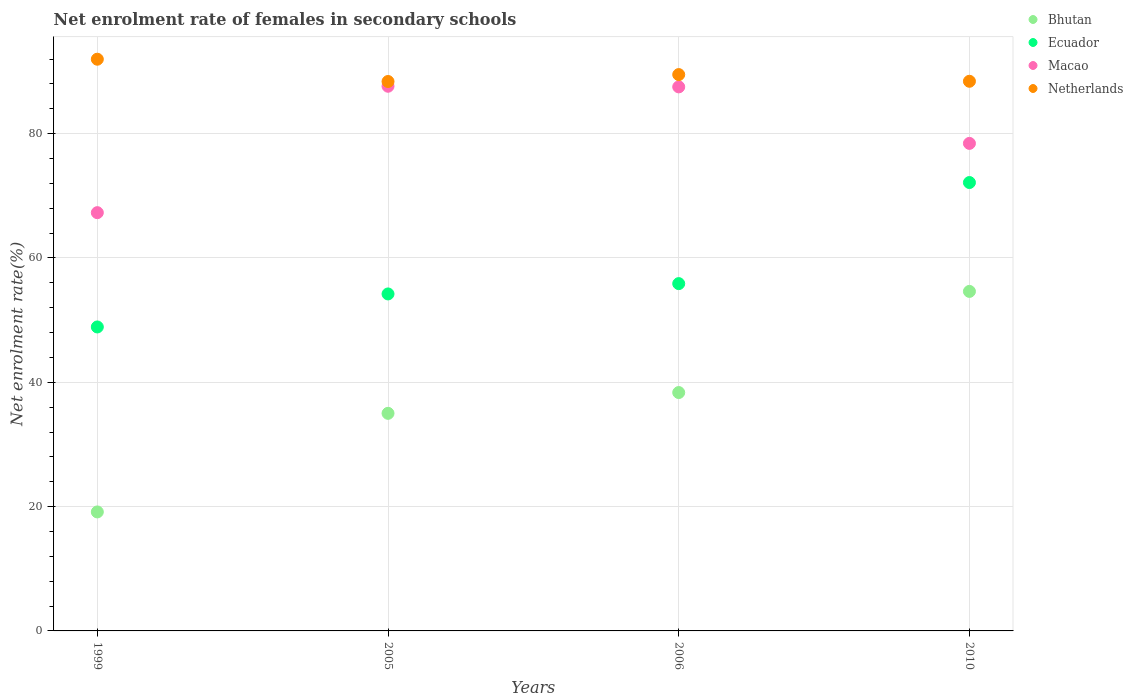How many different coloured dotlines are there?
Provide a succinct answer. 4. What is the net enrolment rate of females in secondary schools in Netherlands in 2010?
Make the answer very short. 88.43. Across all years, what is the maximum net enrolment rate of females in secondary schools in Netherlands?
Your answer should be very brief. 91.98. Across all years, what is the minimum net enrolment rate of females in secondary schools in Ecuador?
Your answer should be compact. 48.9. In which year was the net enrolment rate of females in secondary schools in Netherlands minimum?
Provide a short and direct response. 2005. What is the total net enrolment rate of females in secondary schools in Netherlands in the graph?
Offer a terse response. 358.3. What is the difference between the net enrolment rate of females in secondary schools in Ecuador in 2005 and that in 2006?
Your answer should be very brief. -1.66. What is the difference between the net enrolment rate of females in secondary schools in Netherlands in 2006 and the net enrolment rate of females in secondary schools in Ecuador in 2010?
Your answer should be compact. 17.37. What is the average net enrolment rate of females in secondary schools in Macao per year?
Offer a very short reply. 80.22. In the year 1999, what is the difference between the net enrolment rate of females in secondary schools in Ecuador and net enrolment rate of females in secondary schools in Netherlands?
Your response must be concise. -43.08. What is the ratio of the net enrolment rate of females in secondary schools in Ecuador in 2005 to that in 2010?
Provide a short and direct response. 0.75. What is the difference between the highest and the second highest net enrolment rate of females in secondary schools in Macao?
Provide a short and direct response. 0.1. What is the difference between the highest and the lowest net enrolment rate of females in secondary schools in Macao?
Your answer should be compact. 20.34. Is the sum of the net enrolment rate of females in secondary schools in Netherlands in 2005 and 2006 greater than the maximum net enrolment rate of females in secondary schools in Macao across all years?
Your response must be concise. Yes. Is it the case that in every year, the sum of the net enrolment rate of females in secondary schools in Bhutan and net enrolment rate of females in secondary schools in Ecuador  is greater than the sum of net enrolment rate of females in secondary schools in Netherlands and net enrolment rate of females in secondary schools in Macao?
Your response must be concise. No. Does the net enrolment rate of females in secondary schools in Bhutan monotonically increase over the years?
Provide a short and direct response. Yes. How many dotlines are there?
Your response must be concise. 4. How many years are there in the graph?
Offer a very short reply. 4. Does the graph contain grids?
Provide a short and direct response. Yes. What is the title of the graph?
Your answer should be very brief. Net enrolment rate of females in secondary schools. Does "Georgia" appear as one of the legend labels in the graph?
Keep it short and to the point. No. What is the label or title of the X-axis?
Offer a terse response. Years. What is the label or title of the Y-axis?
Your response must be concise. Net enrolment rate(%). What is the Net enrolment rate(%) in Bhutan in 1999?
Your answer should be compact. 19.14. What is the Net enrolment rate(%) in Ecuador in 1999?
Provide a succinct answer. 48.9. What is the Net enrolment rate(%) of Macao in 1999?
Your answer should be very brief. 67.29. What is the Net enrolment rate(%) in Netherlands in 1999?
Offer a very short reply. 91.98. What is the Net enrolment rate(%) of Bhutan in 2005?
Your response must be concise. 35.01. What is the Net enrolment rate(%) of Ecuador in 2005?
Keep it short and to the point. 54.21. What is the Net enrolment rate(%) in Macao in 2005?
Make the answer very short. 87.63. What is the Net enrolment rate(%) of Netherlands in 2005?
Offer a very short reply. 88.39. What is the Net enrolment rate(%) of Bhutan in 2006?
Ensure brevity in your answer.  38.35. What is the Net enrolment rate(%) in Ecuador in 2006?
Your answer should be very brief. 55.87. What is the Net enrolment rate(%) of Macao in 2006?
Offer a very short reply. 87.53. What is the Net enrolment rate(%) in Netherlands in 2006?
Provide a succinct answer. 89.5. What is the Net enrolment rate(%) in Bhutan in 2010?
Your answer should be very brief. 54.62. What is the Net enrolment rate(%) of Ecuador in 2010?
Give a very brief answer. 72.14. What is the Net enrolment rate(%) of Macao in 2010?
Your answer should be very brief. 78.43. What is the Net enrolment rate(%) in Netherlands in 2010?
Provide a succinct answer. 88.43. Across all years, what is the maximum Net enrolment rate(%) of Bhutan?
Offer a very short reply. 54.62. Across all years, what is the maximum Net enrolment rate(%) in Ecuador?
Provide a short and direct response. 72.14. Across all years, what is the maximum Net enrolment rate(%) of Macao?
Your response must be concise. 87.63. Across all years, what is the maximum Net enrolment rate(%) of Netherlands?
Your answer should be very brief. 91.98. Across all years, what is the minimum Net enrolment rate(%) of Bhutan?
Your answer should be very brief. 19.14. Across all years, what is the minimum Net enrolment rate(%) in Ecuador?
Provide a short and direct response. 48.9. Across all years, what is the minimum Net enrolment rate(%) of Macao?
Your answer should be very brief. 67.29. Across all years, what is the minimum Net enrolment rate(%) of Netherlands?
Offer a terse response. 88.39. What is the total Net enrolment rate(%) in Bhutan in the graph?
Give a very brief answer. 147.12. What is the total Net enrolment rate(%) in Ecuador in the graph?
Offer a terse response. 231.13. What is the total Net enrolment rate(%) of Macao in the graph?
Your response must be concise. 320.88. What is the total Net enrolment rate(%) of Netherlands in the graph?
Ensure brevity in your answer.  358.3. What is the difference between the Net enrolment rate(%) of Bhutan in 1999 and that in 2005?
Offer a very short reply. -15.86. What is the difference between the Net enrolment rate(%) in Ecuador in 1999 and that in 2005?
Provide a succinct answer. -5.31. What is the difference between the Net enrolment rate(%) of Macao in 1999 and that in 2005?
Your answer should be compact. -20.34. What is the difference between the Net enrolment rate(%) in Netherlands in 1999 and that in 2005?
Keep it short and to the point. 3.58. What is the difference between the Net enrolment rate(%) of Bhutan in 1999 and that in 2006?
Provide a succinct answer. -19.21. What is the difference between the Net enrolment rate(%) in Ecuador in 1999 and that in 2006?
Offer a terse response. -6.97. What is the difference between the Net enrolment rate(%) of Macao in 1999 and that in 2006?
Offer a very short reply. -20.24. What is the difference between the Net enrolment rate(%) of Netherlands in 1999 and that in 2006?
Offer a terse response. 2.47. What is the difference between the Net enrolment rate(%) in Bhutan in 1999 and that in 2010?
Offer a terse response. -35.48. What is the difference between the Net enrolment rate(%) of Ecuador in 1999 and that in 2010?
Offer a very short reply. -23.23. What is the difference between the Net enrolment rate(%) of Macao in 1999 and that in 2010?
Provide a succinct answer. -11.14. What is the difference between the Net enrolment rate(%) in Netherlands in 1999 and that in 2010?
Your answer should be compact. 3.55. What is the difference between the Net enrolment rate(%) in Bhutan in 2005 and that in 2006?
Your response must be concise. -3.34. What is the difference between the Net enrolment rate(%) in Ecuador in 2005 and that in 2006?
Offer a very short reply. -1.66. What is the difference between the Net enrolment rate(%) of Macao in 2005 and that in 2006?
Offer a terse response. 0.1. What is the difference between the Net enrolment rate(%) in Netherlands in 2005 and that in 2006?
Ensure brevity in your answer.  -1.11. What is the difference between the Net enrolment rate(%) in Bhutan in 2005 and that in 2010?
Keep it short and to the point. -19.62. What is the difference between the Net enrolment rate(%) in Ecuador in 2005 and that in 2010?
Give a very brief answer. -17.92. What is the difference between the Net enrolment rate(%) in Macao in 2005 and that in 2010?
Ensure brevity in your answer.  9.19. What is the difference between the Net enrolment rate(%) in Netherlands in 2005 and that in 2010?
Keep it short and to the point. -0.04. What is the difference between the Net enrolment rate(%) in Bhutan in 2006 and that in 2010?
Your answer should be very brief. -16.27. What is the difference between the Net enrolment rate(%) of Ecuador in 2006 and that in 2010?
Offer a very short reply. -16.26. What is the difference between the Net enrolment rate(%) of Macao in 2006 and that in 2010?
Offer a very short reply. 9.09. What is the difference between the Net enrolment rate(%) of Netherlands in 2006 and that in 2010?
Keep it short and to the point. 1.08. What is the difference between the Net enrolment rate(%) in Bhutan in 1999 and the Net enrolment rate(%) in Ecuador in 2005?
Give a very brief answer. -35.07. What is the difference between the Net enrolment rate(%) in Bhutan in 1999 and the Net enrolment rate(%) in Macao in 2005?
Make the answer very short. -68.49. What is the difference between the Net enrolment rate(%) in Bhutan in 1999 and the Net enrolment rate(%) in Netherlands in 2005?
Your response must be concise. -69.25. What is the difference between the Net enrolment rate(%) of Ecuador in 1999 and the Net enrolment rate(%) of Macao in 2005?
Your answer should be compact. -38.73. What is the difference between the Net enrolment rate(%) of Ecuador in 1999 and the Net enrolment rate(%) of Netherlands in 2005?
Offer a very short reply. -39.49. What is the difference between the Net enrolment rate(%) of Macao in 1999 and the Net enrolment rate(%) of Netherlands in 2005?
Your response must be concise. -21.1. What is the difference between the Net enrolment rate(%) of Bhutan in 1999 and the Net enrolment rate(%) of Ecuador in 2006?
Your answer should be very brief. -36.73. What is the difference between the Net enrolment rate(%) in Bhutan in 1999 and the Net enrolment rate(%) in Macao in 2006?
Your answer should be very brief. -68.38. What is the difference between the Net enrolment rate(%) in Bhutan in 1999 and the Net enrolment rate(%) in Netherlands in 2006?
Ensure brevity in your answer.  -70.36. What is the difference between the Net enrolment rate(%) of Ecuador in 1999 and the Net enrolment rate(%) of Macao in 2006?
Your answer should be compact. -38.62. What is the difference between the Net enrolment rate(%) of Ecuador in 1999 and the Net enrolment rate(%) of Netherlands in 2006?
Your answer should be compact. -40.6. What is the difference between the Net enrolment rate(%) in Macao in 1999 and the Net enrolment rate(%) in Netherlands in 2006?
Provide a succinct answer. -22.21. What is the difference between the Net enrolment rate(%) of Bhutan in 1999 and the Net enrolment rate(%) of Ecuador in 2010?
Make the answer very short. -52.99. What is the difference between the Net enrolment rate(%) in Bhutan in 1999 and the Net enrolment rate(%) in Macao in 2010?
Offer a very short reply. -59.29. What is the difference between the Net enrolment rate(%) in Bhutan in 1999 and the Net enrolment rate(%) in Netherlands in 2010?
Your answer should be compact. -69.28. What is the difference between the Net enrolment rate(%) in Ecuador in 1999 and the Net enrolment rate(%) in Macao in 2010?
Make the answer very short. -29.53. What is the difference between the Net enrolment rate(%) of Ecuador in 1999 and the Net enrolment rate(%) of Netherlands in 2010?
Keep it short and to the point. -39.53. What is the difference between the Net enrolment rate(%) of Macao in 1999 and the Net enrolment rate(%) of Netherlands in 2010?
Make the answer very short. -21.14. What is the difference between the Net enrolment rate(%) in Bhutan in 2005 and the Net enrolment rate(%) in Ecuador in 2006?
Make the answer very short. -20.87. What is the difference between the Net enrolment rate(%) in Bhutan in 2005 and the Net enrolment rate(%) in Macao in 2006?
Ensure brevity in your answer.  -52.52. What is the difference between the Net enrolment rate(%) of Bhutan in 2005 and the Net enrolment rate(%) of Netherlands in 2006?
Provide a succinct answer. -54.5. What is the difference between the Net enrolment rate(%) in Ecuador in 2005 and the Net enrolment rate(%) in Macao in 2006?
Make the answer very short. -33.31. What is the difference between the Net enrolment rate(%) in Ecuador in 2005 and the Net enrolment rate(%) in Netherlands in 2006?
Your answer should be compact. -35.29. What is the difference between the Net enrolment rate(%) in Macao in 2005 and the Net enrolment rate(%) in Netherlands in 2006?
Your answer should be very brief. -1.88. What is the difference between the Net enrolment rate(%) in Bhutan in 2005 and the Net enrolment rate(%) in Ecuador in 2010?
Your answer should be compact. -37.13. What is the difference between the Net enrolment rate(%) in Bhutan in 2005 and the Net enrolment rate(%) in Macao in 2010?
Keep it short and to the point. -43.43. What is the difference between the Net enrolment rate(%) in Bhutan in 2005 and the Net enrolment rate(%) in Netherlands in 2010?
Make the answer very short. -53.42. What is the difference between the Net enrolment rate(%) in Ecuador in 2005 and the Net enrolment rate(%) in Macao in 2010?
Your response must be concise. -24.22. What is the difference between the Net enrolment rate(%) in Ecuador in 2005 and the Net enrolment rate(%) in Netherlands in 2010?
Your response must be concise. -34.21. What is the difference between the Net enrolment rate(%) in Macao in 2005 and the Net enrolment rate(%) in Netherlands in 2010?
Make the answer very short. -0.8. What is the difference between the Net enrolment rate(%) in Bhutan in 2006 and the Net enrolment rate(%) in Ecuador in 2010?
Offer a very short reply. -33.79. What is the difference between the Net enrolment rate(%) in Bhutan in 2006 and the Net enrolment rate(%) in Macao in 2010?
Your response must be concise. -40.08. What is the difference between the Net enrolment rate(%) in Bhutan in 2006 and the Net enrolment rate(%) in Netherlands in 2010?
Make the answer very short. -50.08. What is the difference between the Net enrolment rate(%) of Ecuador in 2006 and the Net enrolment rate(%) of Macao in 2010?
Provide a short and direct response. -22.56. What is the difference between the Net enrolment rate(%) in Ecuador in 2006 and the Net enrolment rate(%) in Netherlands in 2010?
Your answer should be compact. -32.55. What is the difference between the Net enrolment rate(%) of Macao in 2006 and the Net enrolment rate(%) of Netherlands in 2010?
Make the answer very short. -0.9. What is the average Net enrolment rate(%) of Bhutan per year?
Make the answer very short. 36.78. What is the average Net enrolment rate(%) in Ecuador per year?
Your answer should be very brief. 57.78. What is the average Net enrolment rate(%) of Macao per year?
Provide a short and direct response. 80.22. What is the average Net enrolment rate(%) of Netherlands per year?
Offer a very short reply. 89.58. In the year 1999, what is the difference between the Net enrolment rate(%) in Bhutan and Net enrolment rate(%) in Ecuador?
Provide a succinct answer. -29.76. In the year 1999, what is the difference between the Net enrolment rate(%) in Bhutan and Net enrolment rate(%) in Macao?
Provide a short and direct response. -48.15. In the year 1999, what is the difference between the Net enrolment rate(%) of Bhutan and Net enrolment rate(%) of Netherlands?
Keep it short and to the point. -72.83. In the year 1999, what is the difference between the Net enrolment rate(%) of Ecuador and Net enrolment rate(%) of Macao?
Give a very brief answer. -18.39. In the year 1999, what is the difference between the Net enrolment rate(%) in Ecuador and Net enrolment rate(%) in Netherlands?
Keep it short and to the point. -43.08. In the year 1999, what is the difference between the Net enrolment rate(%) in Macao and Net enrolment rate(%) in Netherlands?
Offer a terse response. -24.69. In the year 2005, what is the difference between the Net enrolment rate(%) of Bhutan and Net enrolment rate(%) of Ecuador?
Make the answer very short. -19.21. In the year 2005, what is the difference between the Net enrolment rate(%) of Bhutan and Net enrolment rate(%) of Macao?
Offer a very short reply. -52.62. In the year 2005, what is the difference between the Net enrolment rate(%) of Bhutan and Net enrolment rate(%) of Netherlands?
Keep it short and to the point. -53.39. In the year 2005, what is the difference between the Net enrolment rate(%) in Ecuador and Net enrolment rate(%) in Macao?
Your response must be concise. -33.41. In the year 2005, what is the difference between the Net enrolment rate(%) of Ecuador and Net enrolment rate(%) of Netherlands?
Your response must be concise. -34.18. In the year 2005, what is the difference between the Net enrolment rate(%) in Macao and Net enrolment rate(%) in Netherlands?
Offer a terse response. -0.76. In the year 2006, what is the difference between the Net enrolment rate(%) of Bhutan and Net enrolment rate(%) of Ecuador?
Give a very brief answer. -17.52. In the year 2006, what is the difference between the Net enrolment rate(%) of Bhutan and Net enrolment rate(%) of Macao?
Keep it short and to the point. -49.18. In the year 2006, what is the difference between the Net enrolment rate(%) in Bhutan and Net enrolment rate(%) in Netherlands?
Ensure brevity in your answer.  -51.15. In the year 2006, what is the difference between the Net enrolment rate(%) in Ecuador and Net enrolment rate(%) in Macao?
Keep it short and to the point. -31.65. In the year 2006, what is the difference between the Net enrolment rate(%) of Ecuador and Net enrolment rate(%) of Netherlands?
Keep it short and to the point. -33.63. In the year 2006, what is the difference between the Net enrolment rate(%) of Macao and Net enrolment rate(%) of Netherlands?
Offer a very short reply. -1.98. In the year 2010, what is the difference between the Net enrolment rate(%) of Bhutan and Net enrolment rate(%) of Ecuador?
Make the answer very short. -17.51. In the year 2010, what is the difference between the Net enrolment rate(%) of Bhutan and Net enrolment rate(%) of Macao?
Ensure brevity in your answer.  -23.81. In the year 2010, what is the difference between the Net enrolment rate(%) in Bhutan and Net enrolment rate(%) in Netherlands?
Your answer should be very brief. -33.81. In the year 2010, what is the difference between the Net enrolment rate(%) in Ecuador and Net enrolment rate(%) in Macao?
Give a very brief answer. -6.3. In the year 2010, what is the difference between the Net enrolment rate(%) of Ecuador and Net enrolment rate(%) of Netherlands?
Give a very brief answer. -16.29. In the year 2010, what is the difference between the Net enrolment rate(%) in Macao and Net enrolment rate(%) in Netherlands?
Provide a succinct answer. -9.99. What is the ratio of the Net enrolment rate(%) of Bhutan in 1999 to that in 2005?
Keep it short and to the point. 0.55. What is the ratio of the Net enrolment rate(%) in Ecuador in 1999 to that in 2005?
Give a very brief answer. 0.9. What is the ratio of the Net enrolment rate(%) of Macao in 1999 to that in 2005?
Your answer should be very brief. 0.77. What is the ratio of the Net enrolment rate(%) of Netherlands in 1999 to that in 2005?
Ensure brevity in your answer.  1.04. What is the ratio of the Net enrolment rate(%) of Bhutan in 1999 to that in 2006?
Provide a succinct answer. 0.5. What is the ratio of the Net enrolment rate(%) of Ecuador in 1999 to that in 2006?
Keep it short and to the point. 0.88. What is the ratio of the Net enrolment rate(%) in Macao in 1999 to that in 2006?
Keep it short and to the point. 0.77. What is the ratio of the Net enrolment rate(%) in Netherlands in 1999 to that in 2006?
Ensure brevity in your answer.  1.03. What is the ratio of the Net enrolment rate(%) of Bhutan in 1999 to that in 2010?
Your answer should be compact. 0.35. What is the ratio of the Net enrolment rate(%) in Ecuador in 1999 to that in 2010?
Provide a succinct answer. 0.68. What is the ratio of the Net enrolment rate(%) of Macao in 1999 to that in 2010?
Offer a terse response. 0.86. What is the ratio of the Net enrolment rate(%) of Netherlands in 1999 to that in 2010?
Offer a very short reply. 1.04. What is the ratio of the Net enrolment rate(%) in Bhutan in 2005 to that in 2006?
Your answer should be compact. 0.91. What is the ratio of the Net enrolment rate(%) in Ecuador in 2005 to that in 2006?
Give a very brief answer. 0.97. What is the ratio of the Net enrolment rate(%) of Netherlands in 2005 to that in 2006?
Provide a succinct answer. 0.99. What is the ratio of the Net enrolment rate(%) of Bhutan in 2005 to that in 2010?
Offer a terse response. 0.64. What is the ratio of the Net enrolment rate(%) of Ecuador in 2005 to that in 2010?
Keep it short and to the point. 0.75. What is the ratio of the Net enrolment rate(%) in Macao in 2005 to that in 2010?
Your answer should be very brief. 1.12. What is the ratio of the Net enrolment rate(%) of Bhutan in 2006 to that in 2010?
Make the answer very short. 0.7. What is the ratio of the Net enrolment rate(%) of Ecuador in 2006 to that in 2010?
Ensure brevity in your answer.  0.77. What is the ratio of the Net enrolment rate(%) in Macao in 2006 to that in 2010?
Your answer should be very brief. 1.12. What is the ratio of the Net enrolment rate(%) of Netherlands in 2006 to that in 2010?
Give a very brief answer. 1.01. What is the difference between the highest and the second highest Net enrolment rate(%) in Bhutan?
Your answer should be very brief. 16.27. What is the difference between the highest and the second highest Net enrolment rate(%) in Ecuador?
Offer a terse response. 16.26. What is the difference between the highest and the second highest Net enrolment rate(%) in Macao?
Ensure brevity in your answer.  0.1. What is the difference between the highest and the second highest Net enrolment rate(%) of Netherlands?
Provide a short and direct response. 2.47. What is the difference between the highest and the lowest Net enrolment rate(%) in Bhutan?
Provide a short and direct response. 35.48. What is the difference between the highest and the lowest Net enrolment rate(%) of Ecuador?
Give a very brief answer. 23.23. What is the difference between the highest and the lowest Net enrolment rate(%) in Macao?
Your answer should be very brief. 20.34. What is the difference between the highest and the lowest Net enrolment rate(%) in Netherlands?
Make the answer very short. 3.58. 